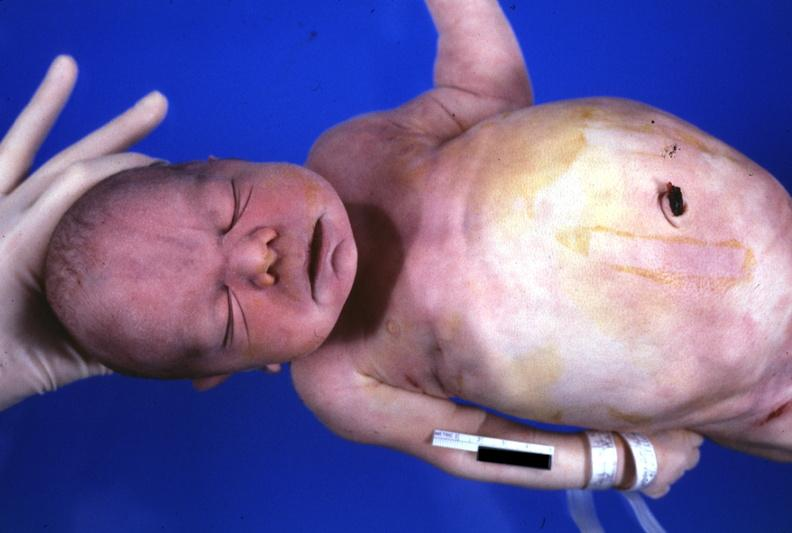s face present?
Answer the question using a single word or phrase. Yes 